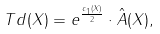Convert formula to latex. <formula><loc_0><loc_0><loc_500><loc_500>T d ( X ) = e ^ { \frac { c _ { 1 } ( X ) } { 2 } } \cdot \hat { A } ( X ) ,</formula> 